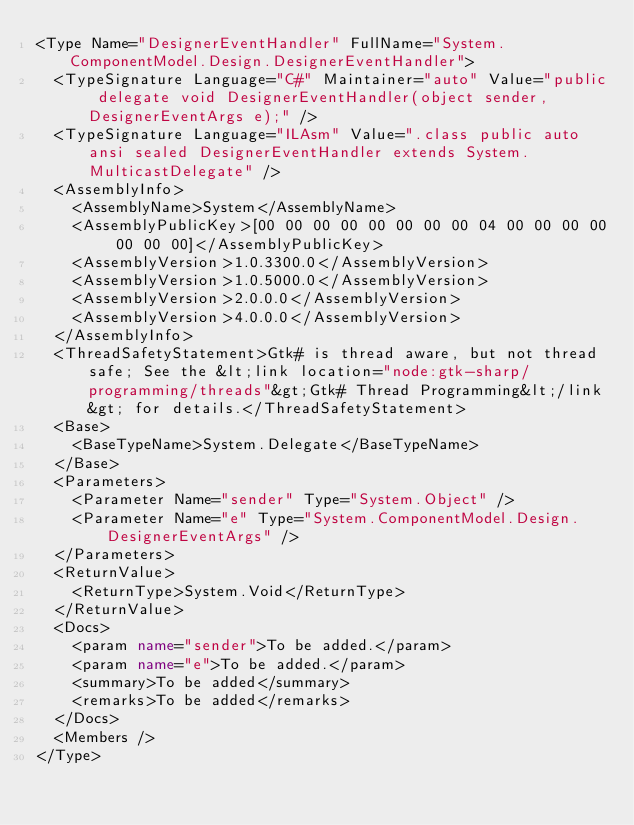Convert code to text. <code><loc_0><loc_0><loc_500><loc_500><_XML_><Type Name="DesignerEventHandler" FullName="System.ComponentModel.Design.DesignerEventHandler">
  <TypeSignature Language="C#" Maintainer="auto" Value="public delegate void DesignerEventHandler(object sender, DesignerEventArgs e);" />
  <TypeSignature Language="ILAsm" Value=".class public auto ansi sealed DesignerEventHandler extends System.MulticastDelegate" />
  <AssemblyInfo>
    <AssemblyName>System</AssemblyName>
    <AssemblyPublicKey>[00 00 00 00 00 00 00 00 04 00 00 00 00 00 00 00]</AssemblyPublicKey>
    <AssemblyVersion>1.0.3300.0</AssemblyVersion>
    <AssemblyVersion>1.0.5000.0</AssemblyVersion>
    <AssemblyVersion>2.0.0.0</AssemblyVersion>
    <AssemblyVersion>4.0.0.0</AssemblyVersion>
  </AssemblyInfo>
  <ThreadSafetyStatement>Gtk# is thread aware, but not thread safe; See the &lt;link location="node:gtk-sharp/programming/threads"&gt;Gtk# Thread Programming&lt;/link&gt; for details.</ThreadSafetyStatement>
  <Base>
    <BaseTypeName>System.Delegate</BaseTypeName>
  </Base>
  <Parameters>
    <Parameter Name="sender" Type="System.Object" />
    <Parameter Name="e" Type="System.ComponentModel.Design.DesignerEventArgs" />
  </Parameters>
  <ReturnValue>
    <ReturnType>System.Void</ReturnType>
  </ReturnValue>
  <Docs>
    <param name="sender">To be added.</param>
    <param name="e">To be added.</param>
    <summary>To be added</summary>
    <remarks>To be added</remarks>
  </Docs>
  <Members />
</Type>
</code> 